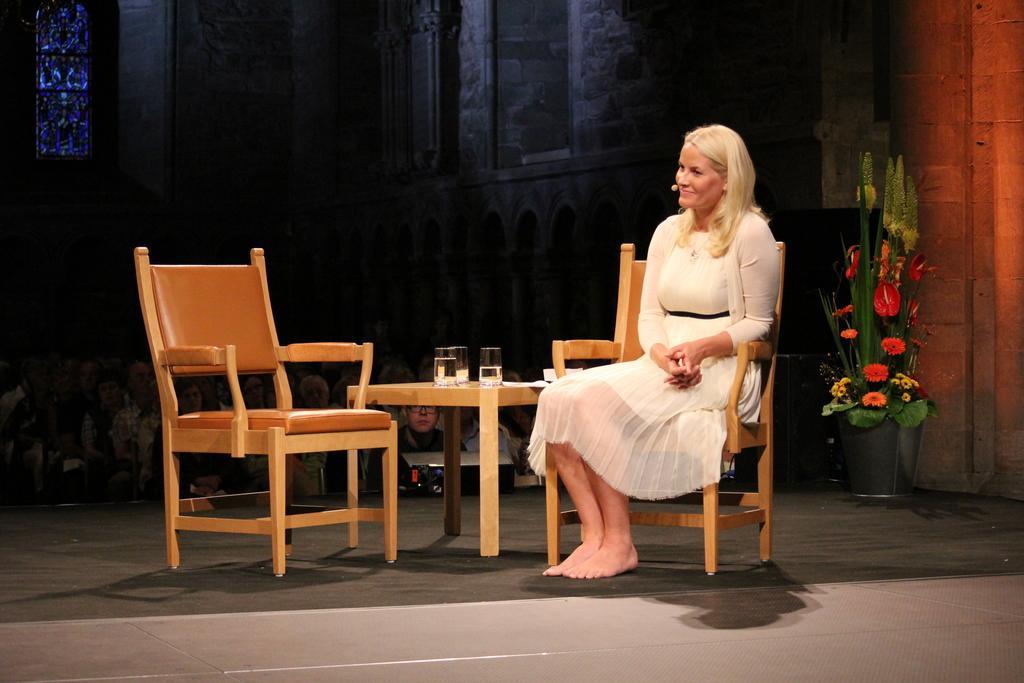How would you summarize this image in a sentence or two? In this image there is a woman sitting in a chair , and there is a table , glass , another chair,and in back ground there are group of people standing , a plant and a window. 